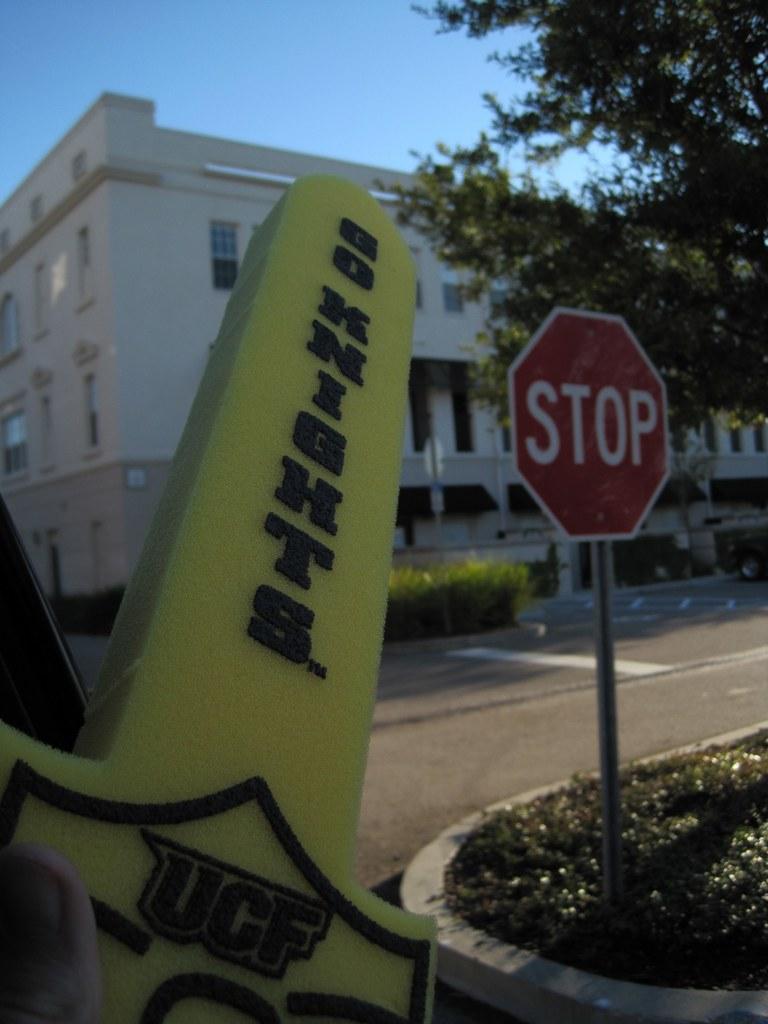How would you summarize this image in a sentence or two? In the image there is a stop sign on the right side on the grass, in the back there is a building with plants and trees in front of it and above its sky. 